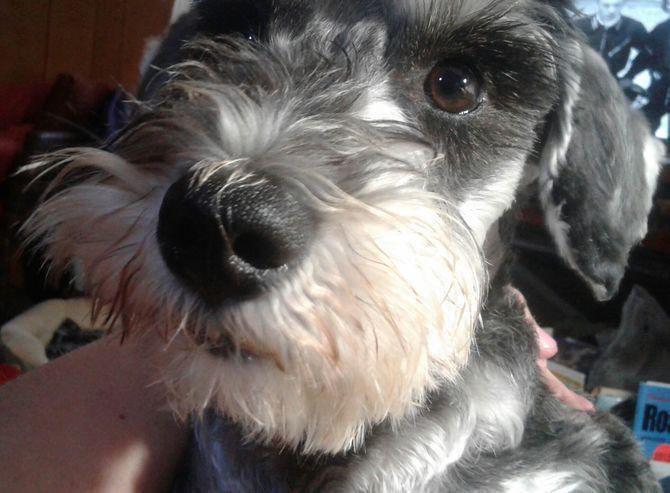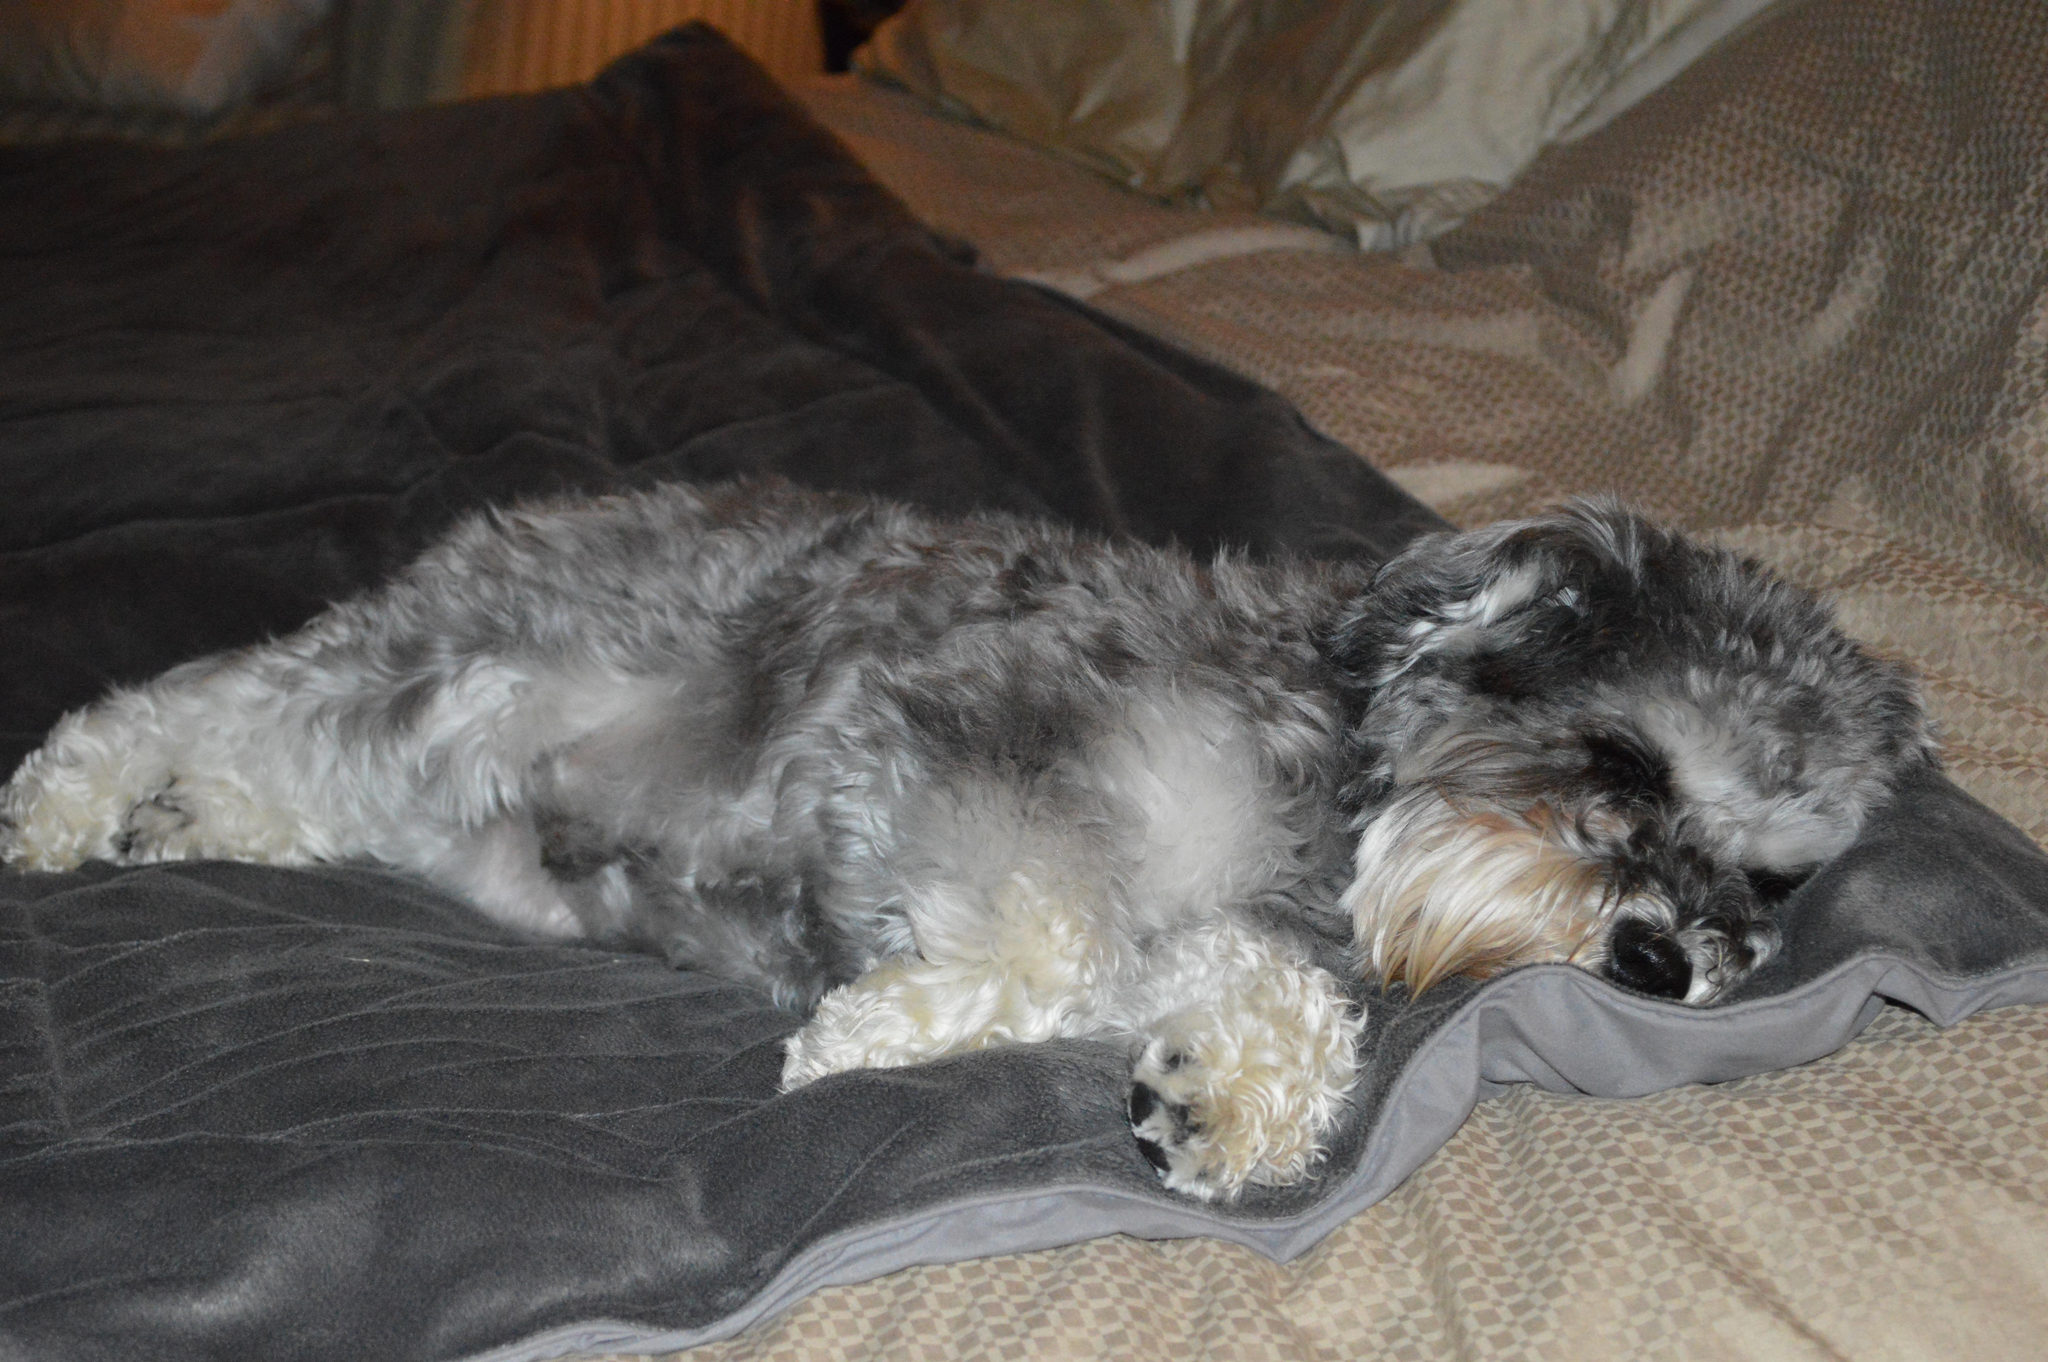The first image is the image on the left, the second image is the image on the right. Analyze the images presented: Is the assertion "One dog is asleep, while another dog is awake." valid? Answer yes or no. Yes. The first image is the image on the left, the second image is the image on the right. Assess this claim about the two images: "Each image shows just one dog, and one is lying down, while the other has an upright head and open eyes.". Correct or not? Answer yes or no. Yes. 